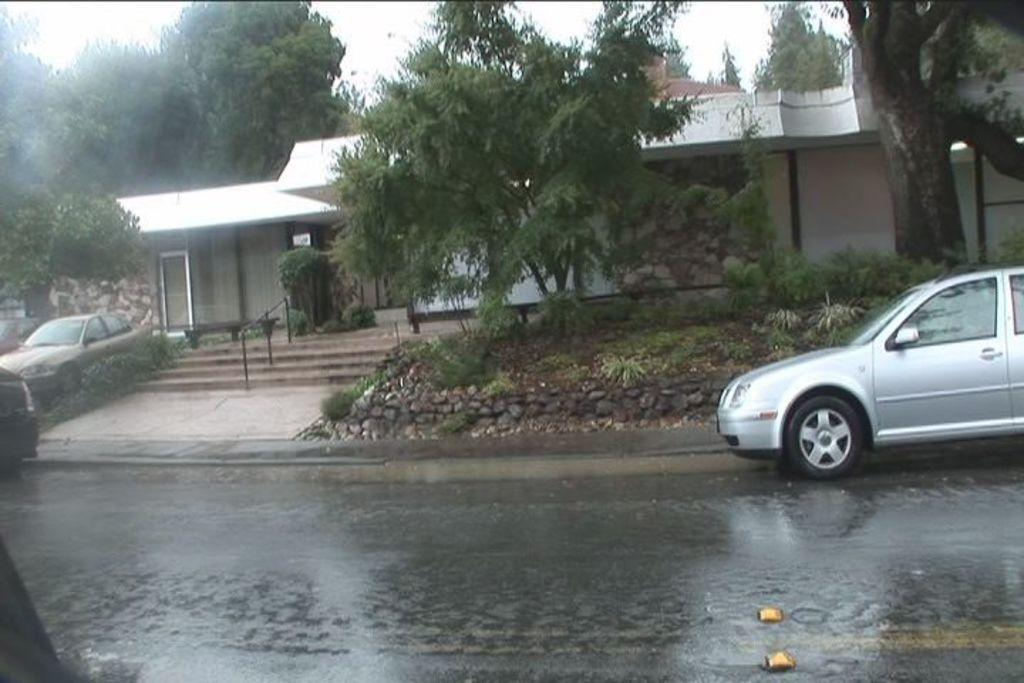What type of structure is visible in the image? There is a house in the image. What natural elements can be seen in the image? There are trees, plants, and rocks visible in the image. Are there any architectural features in the image? Yes, there are stairs in the image. What is present on the road in the image? There are vehicles on the road on both the left and right sides of the image. What can be seen in the background of the image? The sky is visible in the background of the image. What type of oil is being used to maintain the plants in the image? There is no mention of oil being used to maintain the plants in the image. The plants appear to be growing naturally without any artificial substances. 